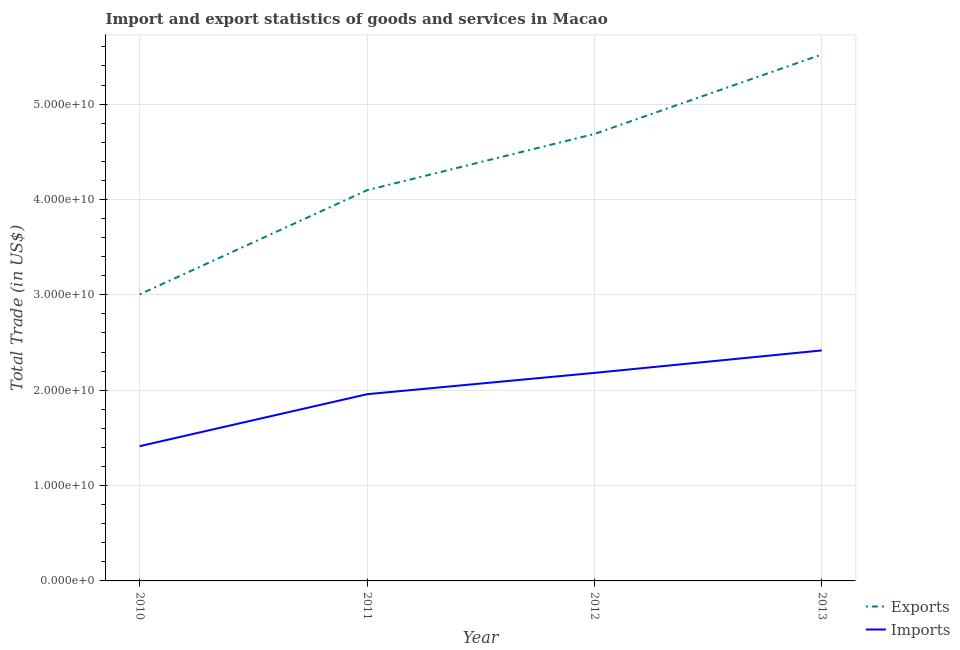Is the number of lines equal to the number of legend labels?
Your response must be concise. Yes. What is the export of goods and services in 2013?
Offer a very short reply. 5.52e+1. Across all years, what is the maximum imports of goods and services?
Your answer should be very brief. 2.42e+1. Across all years, what is the minimum imports of goods and services?
Your response must be concise. 1.41e+1. In which year was the imports of goods and services minimum?
Your answer should be compact. 2010. What is the total imports of goods and services in the graph?
Provide a succinct answer. 7.97e+1. What is the difference between the export of goods and services in 2010 and that in 2011?
Offer a very short reply. -1.09e+1. What is the difference between the imports of goods and services in 2012 and the export of goods and services in 2010?
Ensure brevity in your answer.  -8.23e+09. What is the average export of goods and services per year?
Ensure brevity in your answer.  4.33e+1. In the year 2013, what is the difference between the export of goods and services and imports of goods and services?
Give a very brief answer. 3.10e+1. In how many years, is the export of goods and services greater than 44000000000 US$?
Your answer should be compact. 2. What is the ratio of the export of goods and services in 2010 to that in 2013?
Your response must be concise. 0.54. What is the difference between the highest and the second highest imports of goods and services?
Your answer should be very brief. 2.36e+09. What is the difference between the highest and the lowest export of goods and services?
Your answer should be compact. 2.52e+1. In how many years, is the imports of goods and services greater than the average imports of goods and services taken over all years?
Keep it short and to the point. 2. Is the sum of the imports of goods and services in 2010 and 2013 greater than the maximum export of goods and services across all years?
Offer a very short reply. No. Does the export of goods and services monotonically increase over the years?
Provide a short and direct response. Yes. Is the imports of goods and services strictly less than the export of goods and services over the years?
Offer a terse response. Yes. How many lines are there?
Your response must be concise. 2. How many years are there in the graph?
Provide a succinct answer. 4. Does the graph contain any zero values?
Offer a terse response. No. Does the graph contain grids?
Offer a very short reply. Yes. Where does the legend appear in the graph?
Offer a terse response. Bottom right. How many legend labels are there?
Make the answer very short. 2. How are the legend labels stacked?
Keep it short and to the point. Vertical. What is the title of the graph?
Offer a very short reply. Import and export statistics of goods and services in Macao. What is the label or title of the X-axis?
Provide a short and direct response. Year. What is the label or title of the Y-axis?
Offer a terse response. Total Trade (in US$). What is the Total Trade (in US$) in Exports in 2010?
Provide a succinct answer. 3.00e+1. What is the Total Trade (in US$) of Imports in 2010?
Your answer should be very brief. 1.41e+1. What is the Total Trade (in US$) of Exports in 2011?
Provide a succinct answer. 4.10e+1. What is the Total Trade (in US$) in Imports in 2011?
Provide a short and direct response. 1.96e+1. What is the Total Trade (in US$) in Exports in 2012?
Your response must be concise. 4.69e+1. What is the Total Trade (in US$) in Imports in 2012?
Provide a short and direct response. 2.18e+1. What is the Total Trade (in US$) in Exports in 2013?
Offer a very short reply. 5.52e+1. What is the Total Trade (in US$) in Imports in 2013?
Provide a succinct answer. 2.42e+1. Across all years, what is the maximum Total Trade (in US$) of Exports?
Provide a short and direct response. 5.52e+1. Across all years, what is the maximum Total Trade (in US$) of Imports?
Your answer should be compact. 2.42e+1. Across all years, what is the minimum Total Trade (in US$) in Exports?
Provide a short and direct response. 3.00e+1. Across all years, what is the minimum Total Trade (in US$) in Imports?
Give a very brief answer. 1.41e+1. What is the total Total Trade (in US$) of Exports in the graph?
Ensure brevity in your answer.  1.73e+11. What is the total Total Trade (in US$) in Imports in the graph?
Your response must be concise. 7.97e+1. What is the difference between the Total Trade (in US$) in Exports in 2010 and that in 2011?
Offer a very short reply. -1.09e+1. What is the difference between the Total Trade (in US$) in Imports in 2010 and that in 2011?
Make the answer very short. -5.45e+09. What is the difference between the Total Trade (in US$) in Exports in 2010 and that in 2012?
Offer a very short reply. -1.68e+1. What is the difference between the Total Trade (in US$) of Imports in 2010 and that in 2012?
Make the answer very short. -7.68e+09. What is the difference between the Total Trade (in US$) in Exports in 2010 and that in 2013?
Your answer should be very brief. -2.52e+1. What is the difference between the Total Trade (in US$) of Imports in 2010 and that in 2013?
Offer a terse response. -1.00e+1. What is the difference between the Total Trade (in US$) of Exports in 2011 and that in 2012?
Offer a very short reply. -5.90e+09. What is the difference between the Total Trade (in US$) of Imports in 2011 and that in 2012?
Make the answer very short. -2.24e+09. What is the difference between the Total Trade (in US$) of Exports in 2011 and that in 2013?
Offer a very short reply. -1.42e+1. What is the difference between the Total Trade (in US$) of Imports in 2011 and that in 2013?
Give a very brief answer. -4.59e+09. What is the difference between the Total Trade (in US$) in Exports in 2012 and that in 2013?
Provide a succinct answer. -8.34e+09. What is the difference between the Total Trade (in US$) in Imports in 2012 and that in 2013?
Offer a terse response. -2.36e+09. What is the difference between the Total Trade (in US$) in Exports in 2010 and the Total Trade (in US$) in Imports in 2011?
Ensure brevity in your answer.  1.05e+1. What is the difference between the Total Trade (in US$) in Exports in 2010 and the Total Trade (in US$) in Imports in 2012?
Provide a succinct answer. 8.23e+09. What is the difference between the Total Trade (in US$) of Exports in 2010 and the Total Trade (in US$) of Imports in 2013?
Ensure brevity in your answer.  5.88e+09. What is the difference between the Total Trade (in US$) in Exports in 2011 and the Total Trade (in US$) in Imports in 2012?
Give a very brief answer. 1.92e+1. What is the difference between the Total Trade (in US$) of Exports in 2011 and the Total Trade (in US$) of Imports in 2013?
Your answer should be very brief. 1.68e+1. What is the difference between the Total Trade (in US$) in Exports in 2012 and the Total Trade (in US$) in Imports in 2013?
Offer a very short reply. 2.27e+1. What is the average Total Trade (in US$) of Exports per year?
Your response must be concise. 4.33e+1. What is the average Total Trade (in US$) in Imports per year?
Offer a terse response. 1.99e+1. In the year 2010, what is the difference between the Total Trade (in US$) of Exports and Total Trade (in US$) of Imports?
Offer a very short reply. 1.59e+1. In the year 2011, what is the difference between the Total Trade (in US$) in Exports and Total Trade (in US$) in Imports?
Your response must be concise. 2.14e+1. In the year 2012, what is the difference between the Total Trade (in US$) in Exports and Total Trade (in US$) in Imports?
Give a very brief answer. 2.51e+1. In the year 2013, what is the difference between the Total Trade (in US$) of Exports and Total Trade (in US$) of Imports?
Provide a succinct answer. 3.10e+1. What is the ratio of the Total Trade (in US$) in Exports in 2010 to that in 2011?
Your answer should be compact. 0.73. What is the ratio of the Total Trade (in US$) in Imports in 2010 to that in 2011?
Ensure brevity in your answer.  0.72. What is the ratio of the Total Trade (in US$) in Exports in 2010 to that in 2012?
Offer a terse response. 0.64. What is the ratio of the Total Trade (in US$) in Imports in 2010 to that in 2012?
Keep it short and to the point. 0.65. What is the ratio of the Total Trade (in US$) in Exports in 2010 to that in 2013?
Your response must be concise. 0.54. What is the ratio of the Total Trade (in US$) of Imports in 2010 to that in 2013?
Your answer should be compact. 0.58. What is the ratio of the Total Trade (in US$) in Exports in 2011 to that in 2012?
Ensure brevity in your answer.  0.87. What is the ratio of the Total Trade (in US$) in Imports in 2011 to that in 2012?
Offer a terse response. 0.9. What is the ratio of the Total Trade (in US$) of Exports in 2011 to that in 2013?
Keep it short and to the point. 0.74. What is the ratio of the Total Trade (in US$) in Imports in 2011 to that in 2013?
Make the answer very short. 0.81. What is the ratio of the Total Trade (in US$) in Exports in 2012 to that in 2013?
Provide a short and direct response. 0.85. What is the ratio of the Total Trade (in US$) in Imports in 2012 to that in 2013?
Provide a short and direct response. 0.9. What is the difference between the highest and the second highest Total Trade (in US$) of Exports?
Provide a succinct answer. 8.34e+09. What is the difference between the highest and the second highest Total Trade (in US$) of Imports?
Your answer should be compact. 2.36e+09. What is the difference between the highest and the lowest Total Trade (in US$) of Exports?
Your answer should be compact. 2.52e+1. What is the difference between the highest and the lowest Total Trade (in US$) of Imports?
Your response must be concise. 1.00e+1. 